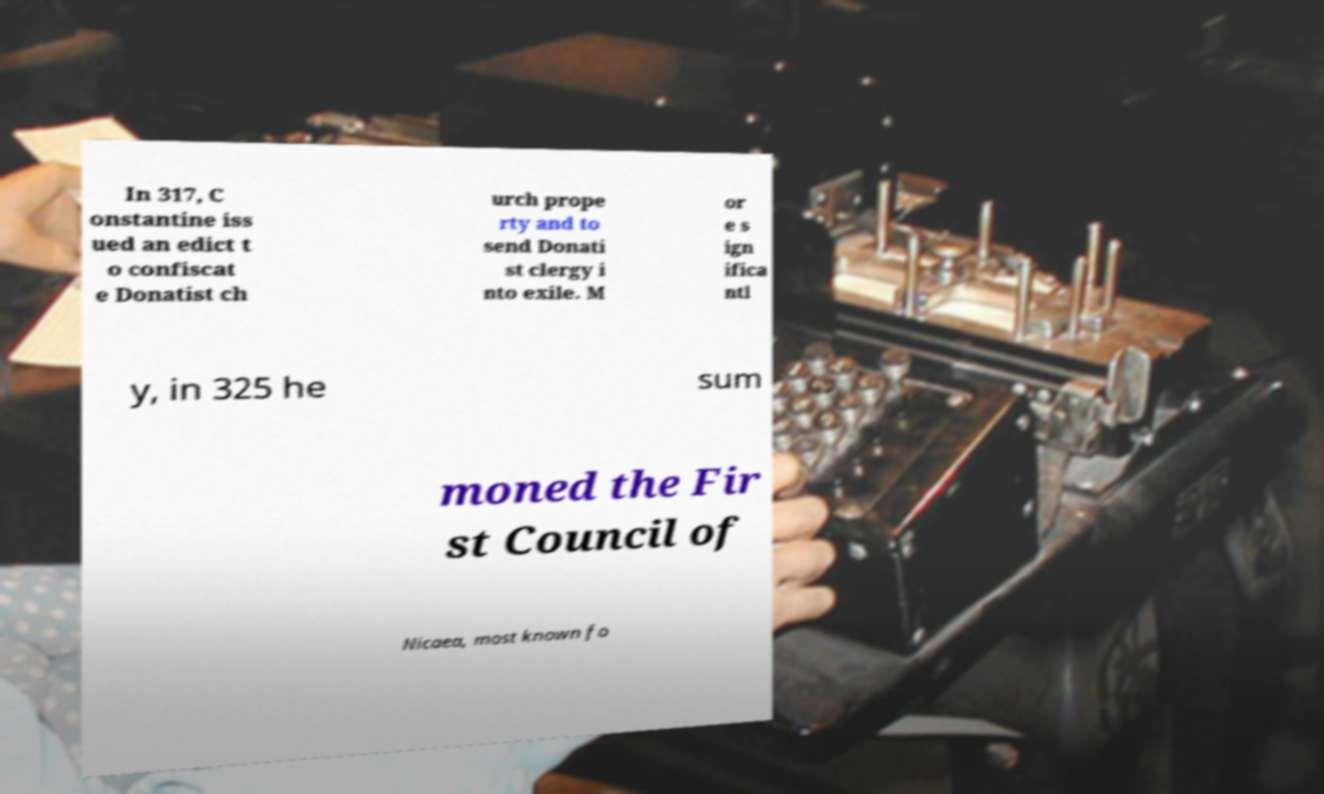Please identify and transcribe the text found in this image. In 317, C onstantine iss ued an edict t o confiscat e Donatist ch urch prope rty and to send Donati st clergy i nto exile. M or e s ign ifica ntl y, in 325 he sum moned the Fir st Council of Nicaea, most known fo 